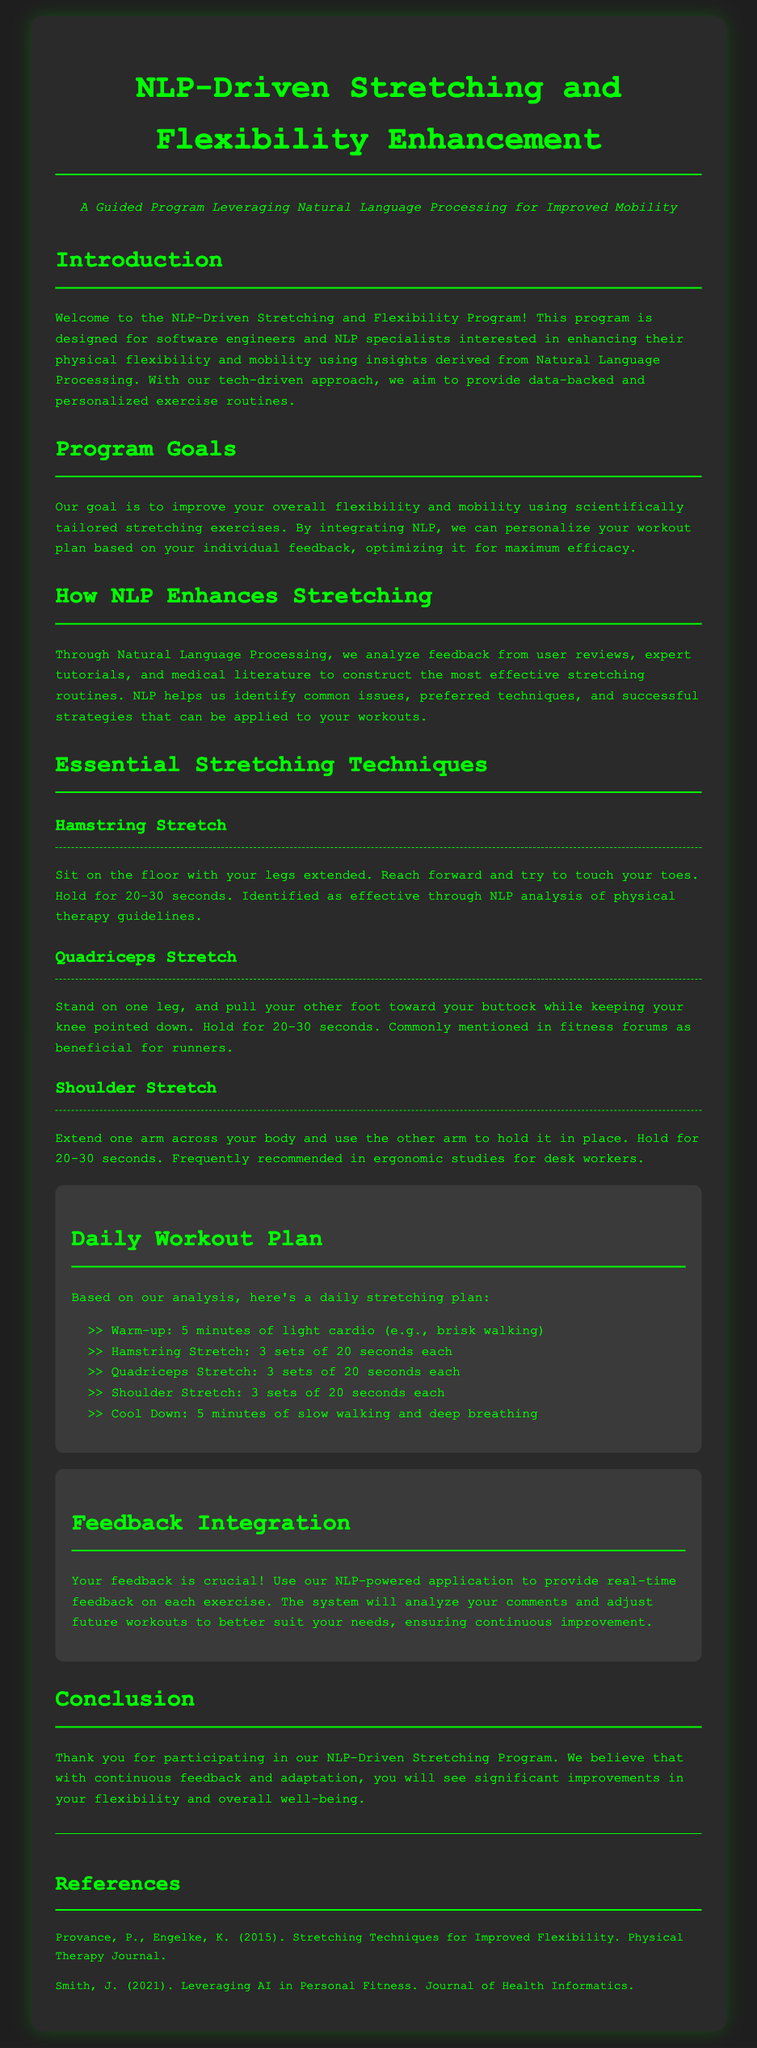what is the main goal of the program? The main goal is to improve overall flexibility and mobility using scientifically tailored stretching exercises.
Answer: improve overall flexibility and mobility how long should you hold the hamstring stretch? The document specifies that the hamstring stretch should be held for 20-30 seconds.
Answer: 20-30 seconds what is one essential stretching technique mentioned? The document lists several techniques; one of them is the Hamstring Stretch.
Answer: Hamstring Stretch how is user feedback utilized in the program? User feedback is analyzed to adjust future workouts to better suit individual needs for continuous improvement.
Answer: adjust future workouts how many sets of the quadriceps stretch are recommended? The workout plan recommends 3 sets of the quadriceps stretch.
Answer: 3 sets what type of application is used for feedback integration? The application is powered by Natural Language Processing.
Answer: Natural Language Processing how many minutes of light cardio are recommended for warm-up? The document states that a warm-up of 5 minutes of light cardio is recommended.
Answer: 5 minutes what should you do during the cool down? The cool down should consist of slow walking and deep breathing.
Answer: slow walking and deep breathing 